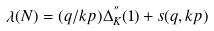<formula> <loc_0><loc_0><loc_500><loc_500>\lambda ( N ) = ( q / k p ) \Delta ^ { ^ { \prime \prime } } _ { K } ( 1 ) + s ( q , k p )</formula> 